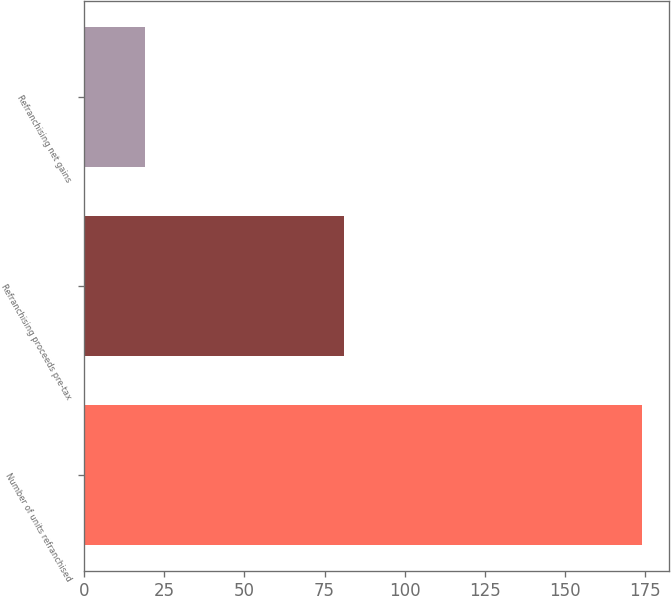<chart> <loc_0><loc_0><loc_500><loc_500><bar_chart><fcel>Number of units refranchised<fcel>Refranchising proceeds pre-tax<fcel>Refranchising net gains<nl><fcel>174<fcel>81<fcel>19<nl></chart> 